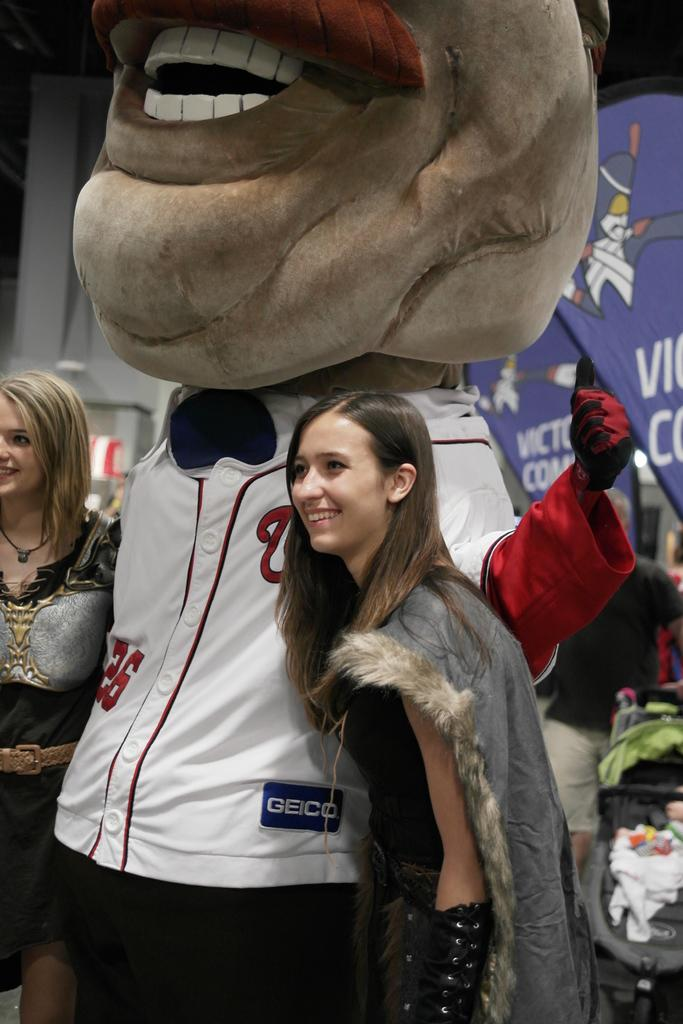<image>
Create a compact narrative representing the image presented. two girls standing with a big headed person wearing a geico shirt 